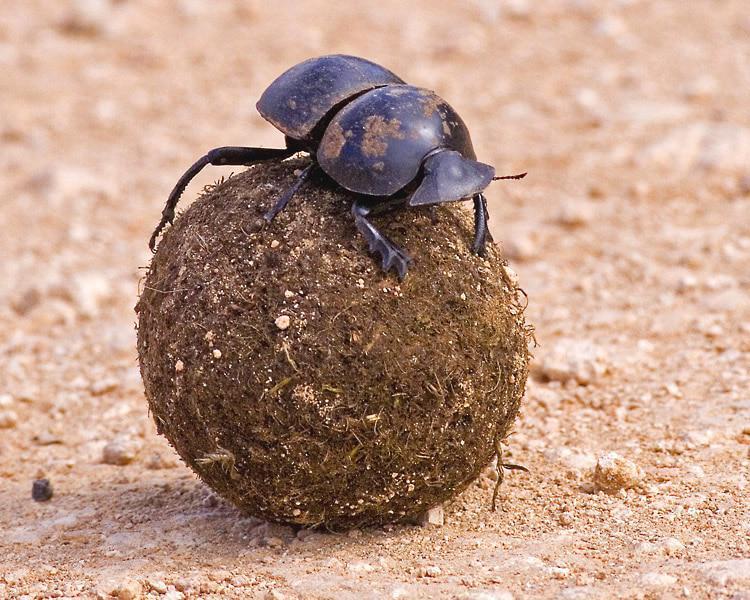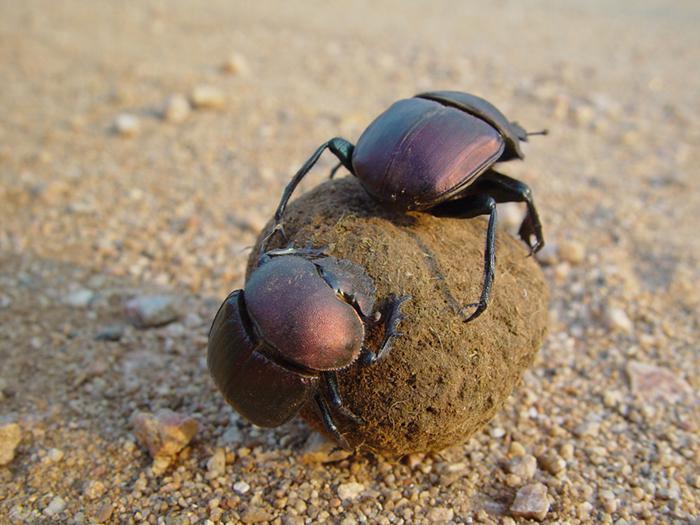The first image is the image on the left, the second image is the image on the right. For the images shown, is this caption "One image includes a beetle that is not in contact with a ball shape, and the other shows a beetle perched on a ball with its front legs touching the ground." true? Answer yes or no. No. 